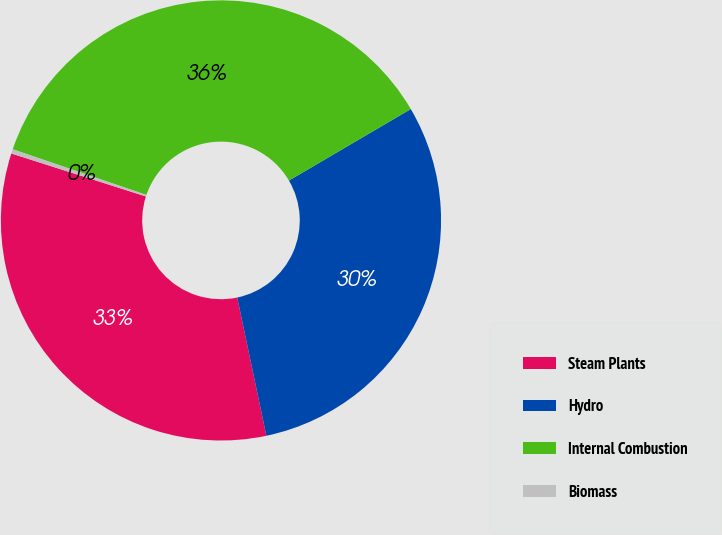Convert chart to OTSL. <chart><loc_0><loc_0><loc_500><loc_500><pie_chart><fcel>Steam Plants<fcel>Hydro<fcel>Internal Combustion<fcel>Biomass<nl><fcel>33.23%<fcel>30.14%<fcel>36.32%<fcel>0.32%<nl></chart> 